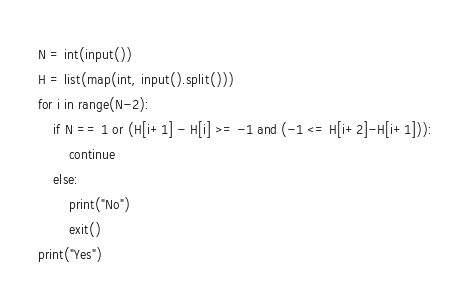Convert code to text. <code><loc_0><loc_0><loc_500><loc_500><_Python_>N = int(input())
H = list(map(int, input().split()))
for i in range(N-2):
    if N == 1 or (H[i+1] - H[i] >= -1 and (-1 <= H[i+2]-H[i+1])):
        continue
    else:
        print("No")
        exit()
print("Yes")</code> 